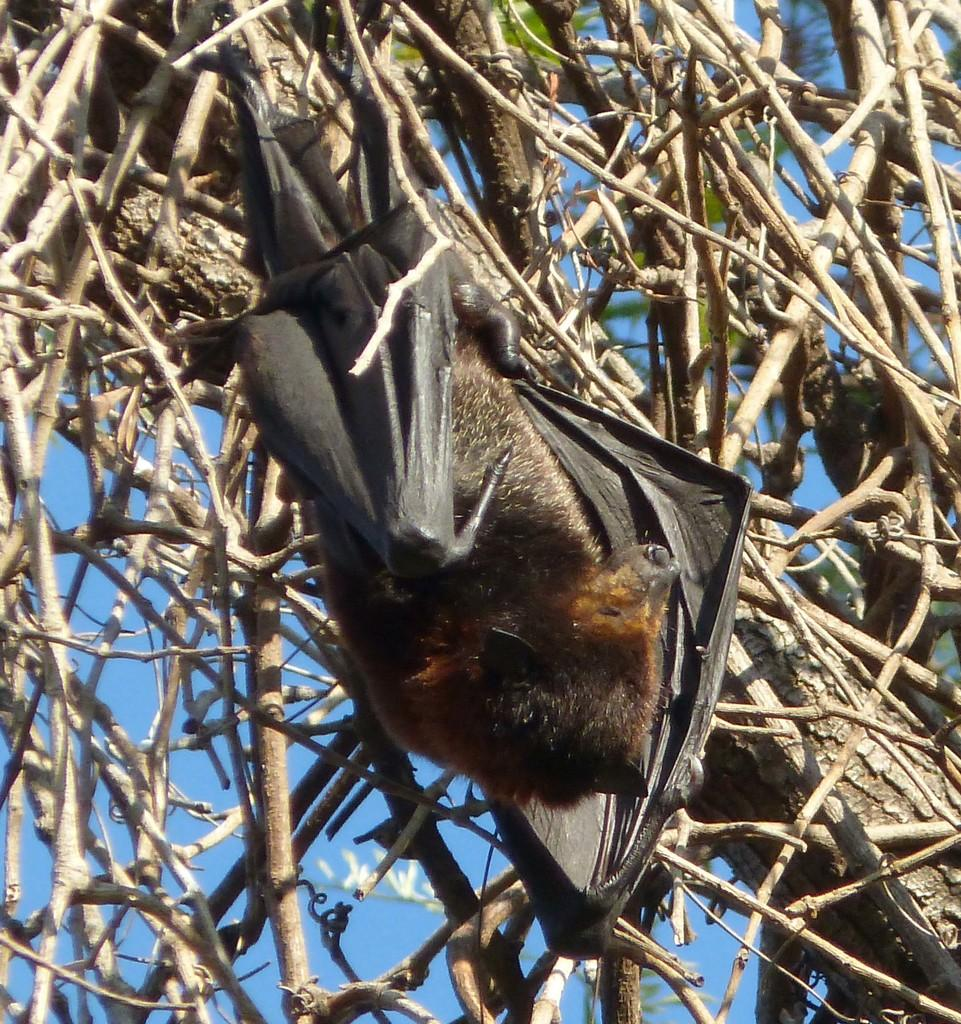What animal is present in the image? There is a bat in the image. What is the bat resting on or near in the image? There are branches in the image. What type of vegetation can be seen in the background of the image? There are leaves in the background of the image. What is visible in the sky in the background of the image? The sky is visible in the background of the image. What type of calendar is hanging on the wall in the image? There is no wall or calendar present in the image; it features a bat resting on branches with leaves and sky in the background. 